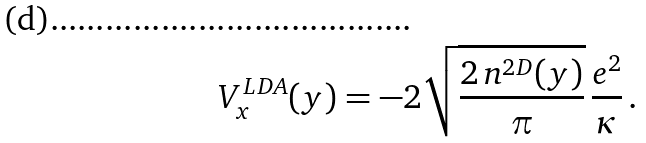<formula> <loc_0><loc_0><loc_500><loc_500>V _ { x } ^ { L D A } ( y ) = - 2 \sqrt { \frac { 2 \, n ^ { 2 D } ( y ) } { \pi } } \, \frac { e ^ { 2 } } { \kappa } \, .</formula> 